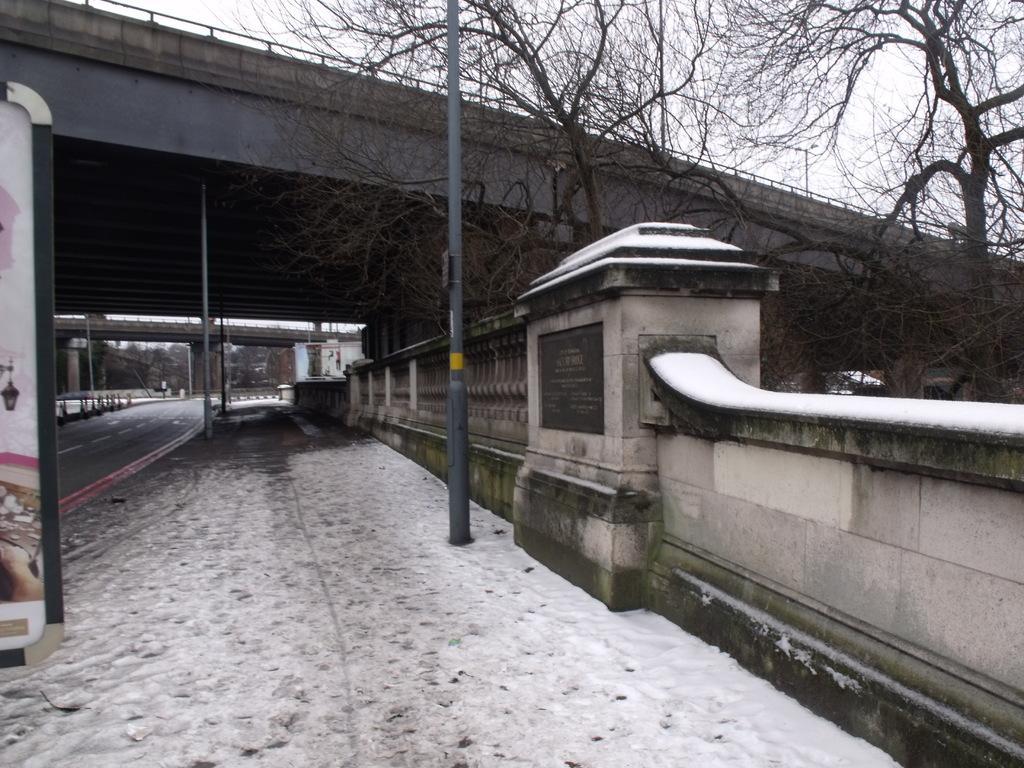Describe this image in one or two sentences. In this image, on the right side, we can see a wall, trees, vehicle and a pole. On the left side, we can also see a hoarding with some pictures. In the background, we can see a pole, bridge, trees, plants, building. At the top, we can see a sky, at the bottom, we can see a footpath and a road. 